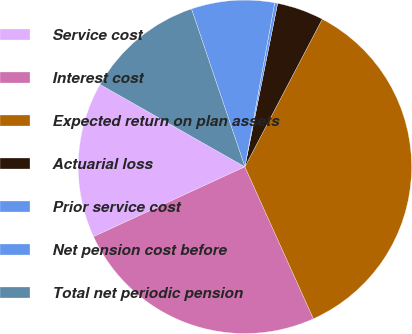Convert chart to OTSL. <chart><loc_0><loc_0><loc_500><loc_500><pie_chart><fcel>Service cost<fcel>Interest cost<fcel>Expected return on plan assets<fcel>Actuarial loss<fcel>Prior service cost<fcel>Net pension cost before<fcel>Total net periodic pension<nl><fcel>15.11%<fcel>24.86%<fcel>35.58%<fcel>4.53%<fcel>0.29%<fcel>8.05%<fcel>11.58%<nl></chart> 